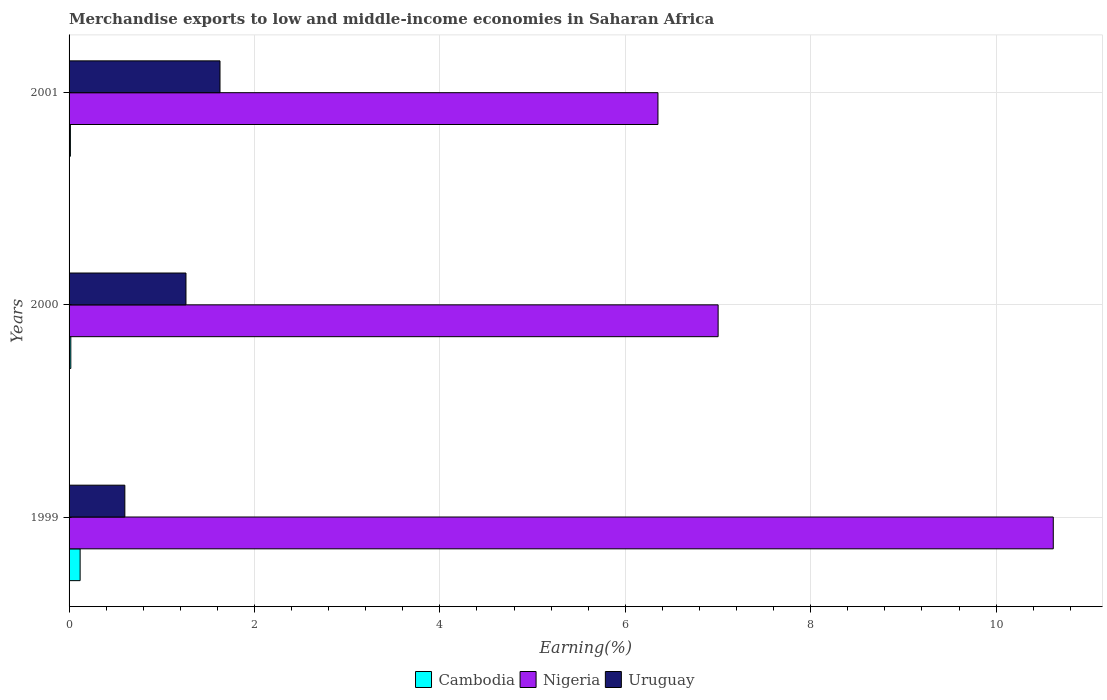Are the number of bars on each tick of the Y-axis equal?
Ensure brevity in your answer.  Yes. How many bars are there on the 2nd tick from the top?
Your response must be concise. 3. How many bars are there on the 3rd tick from the bottom?
Your answer should be compact. 3. What is the label of the 1st group of bars from the top?
Ensure brevity in your answer.  2001. What is the percentage of amount earned from merchandise exports in Nigeria in 2001?
Offer a terse response. 6.35. Across all years, what is the maximum percentage of amount earned from merchandise exports in Uruguay?
Give a very brief answer. 1.63. Across all years, what is the minimum percentage of amount earned from merchandise exports in Nigeria?
Your answer should be very brief. 6.35. What is the total percentage of amount earned from merchandise exports in Cambodia in the graph?
Offer a very short reply. 0.15. What is the difference between the percentage of amount earned from merchandise exports in Nigeria in 1999 and that in 2001?
Your answer should be very brief. 4.26. What is the difference between the percentage of amount earned from merchandise exports in Uruguay in 2000 and the percentage of amount earned from merchandise exports in Nigeria in 2001?
Your answer should be compact. -5.09. What is the average percentage of amount earned from merchandise exports in Uruguay per year?
Offer a terse response. 1.16. In the year 2001, what is the difference between the percentage of amount earned from merchandise exports in Nigeria and percentage of amount earned from merchandise exports in Uruguay?
Your response must be concise. 4.72. What is the ratio of the percentage of amount earned from merchandise exports in Uruguay in 1999 to that in 2001?
Your answer should be very brief. 0.37. Is the difference between the percentage of amount earned from merchandise exports in Nigeria in 1999 and 2001 greater than the difference between the percentage of amount earned from merchandise exports in Uruguay in 1999 and 2001?
Ensure brevity in your answer.  Yes. What is the difference between the highest and the second highest percentage of amount earned from merchandise exports in Nigeria?
Your answer should be very brief. 3.62. What is the difference between the highest and the lowest percentage of amount earned from merchandise exports in Nigeria?
Your answer should be compact. 4.26. In how many years, is the percentage of amount earned from merchandise exports in Uruguay greater than the average percentage of amount earned from merchandise exports in Uruguay taken over all years?
Your answer should be compact. 2. Is the sum of the percentage of amount earned from merchandise exports in Uruguay in 1999 and 2001 greater than the maximum percentage of amount earned from merchandise exports in Nigeria across all years?
Provide a succinct answer. No. What does the 2nd bar from the top in 1999 represents?
Your answer should be compact. Nigeria. What does the 2nd bar from the bottom in 2000 represents?
Keep it short and to the point. Nigeria. How many bars are there?
Give a very brief answer. 9. How many years are there in the graph?
Ensure brevity in your answer.  3. What is the difference between two consecutive major ticks on the X-axis?
Keep it short and to the point. 2. Are the values on the major ticks of X-axis written in scientific E-notation?
Offer a terse response. No. Does the graph contain grids?
Provide a succinct answer. Yes. How many legend labels are there?
Make the answer very short. 3. How are the legend labels stacked?
Make the answer very short. Horizontal. What is the title of the graph?
Your answer should be very brief. Merchandise exports to low and middle-income economies in Saharan Africa. What is the label or title of the X-axis?
Your response must be concise. Earning(%). What is the Earning(%) in Cambodia in 1999?
Offer a terse response. 0.12. What is the Earning(%) in Nigeria in 1999?
Provide a short and direct response. 10.62. What is the Earning(%) in Uruguay in 1999?
Provide a succinct answer. 0.6. What is the Earning(%) of Cambodia in 2000?
Provide a short and direct response. 0.02. What is the Earning(%) in Nigeria in 2000?
Make the answer very short. 7. What is the Earning(%) in Uruguay in 2000?
Ensure brevity in your answer.  1.26. What is the Earning(%) of Cambodia in 2001?
Offer a terse response. 0.01. What is the Earning(%) in Nigeria in 2001?
Give a very brief answer. 6.35. What is the Earning(%) in Uruguay in 2001?
Make the answer very short. 1.63. Across all years, what is the maximum Earning(%) of Cambodia?
Give a very brief answer. 0.12. Across all years, what is the maximum Earning(%) of Nigeria?
Give a very brief answer. 10.62. Across all years, what is the maximum Earning(%) of Uruguay?
Offer a terse response. 1.63. Across all years, what is the minimum Earning(%) of Cambodia?
Give a very brief answer. 0.01. Across all years, what is the minimum Earning(%) of Nigeria?
Provide a short and direct response. 6.35. Across all years, what is the minimum Earning(%) in Uruguay?
Your answer should be compact. 0.6. What is the total Earning(%) of Cambodia in the graph?
Give a very brief answer. 0.15. What is the total Earning(%) in Nigeria in the graph?
Your answer should be very brief. 23.97. What is the total Earning(%) of Uruguay in the graph?
Offer a very short reply. 3.49. What is the difference between the Earning(%) in Cambodia in 1999 and that in 2000?
Your response must be concise. 0.1. What is the difference between the Earning(%) of Nigeria in 1999 and that in 2000?
Ensure brevity in your answer.  3.62. What is the difference between the Earning(%) of Uruguay in 1999 and that in 2000?
Give a very brief answer. -0.66. What is the difference between the Earning(%) in Cambodia in 1999 and that in 2001?
Keep it short and to the point. 0.11. What is the difference between the Earning(%) in Nigeria in 1999 and that in 2001?
Your response must be concise. 4.26. What is the difference between the Earning(%) in Uruguay in 1999 and that in 2001?
Provide a succinct answer. -1.03. What is the difference between the Earning(%) of Cambodia in 2000 and that in 2001?
Give a very brief answer. 0. What is the difference between the Earning(%) in Nigeria in 2000 and that in 2001?
Offer a very short reply. 0.65. What is the difference between the Earning(%) in Uruguay in 2000 and that in 2001?
Provide a short and direct response. -0.37. What is the difference between the Earning(%) of Cambodia in 1999 and the Earning(%) of Nigeria in 2000?
Make the answer very short. -6.88. What is the difference between the Earning(%) of Cambodia in 1999 and the Earning(%) of Uruguay in 2000?
Your answer should be compact. -1.14. What is the difference between the Earning(%) in Nigeria in 1999 and the Earning(%) in Uruguay in 2000?
Keep it short and to the point. 9.36. What is the difference between the Earning(%) in Cambodia in 1999 and the Earning(%) in Nigeria in 2001?
Your response must be concise. -6.23. What is the difference between the Earning(%) in Cambodia in 1999 and the Earning(%) in Uruguay in 2001?
Offer a terse response. -1.51. What is the difference between the Earning(%) of Nigeria in 1999 and the Earning(%) of Uruguay in 2001?
Give a very brief answer. 8.99. What is the difference between the Earning(%) in Cambodia in 2000 and the Earning(%) in Nigeria in 2001?
Provide a short and direct response. -6.33. What is the difference between the Earning(%) of Cambodia in 2000 and the Earning(%) of Uruguay in 2001?
Ensure brevity in your answer.  -1.61. What is the difference between the Earning(%) in Nigeria in 2000 and the Earning(%) in Uruguay in 2001?
Provide a succinct answer. 5.37. What is the average Earning(%) in Cambodia per year?
Provide a short and direct response. 0.05. What is the average Earning(%) in Nigeria per year?
Offer a very short reply. 7.99. What is the average Earning(%) in Uruguay per year?
Provide a short and direct response. 1.16. In the year 1999, what is the difference between the Earning(%) of Cambodia and Earning(%) of Nigeria?
Provide a succinct answer. -10.5. In the year 1999, what is the difference between the Earning(%) in Cambodia and Earning(%) in Uruguay?
Give a very brief answer. -0.48. In the year 1999, what is the difference between the Earning(%) of Nigeria and Earning(%) of Uruguay?
Make the answer very short. 10.02. In the year 2000, what is the difference between the Earning(%) in Cambodia and Earning(%) in Nigeria?
Provide a succinct answer. -6.98. In the year 2000, what is the difference between the Earning(%) in Cambodia and Earning(%) in Uruguay?
Your answer should be very brief. -1.24. In the year 2000, what is the difference between the Earning(%) in Nigeria and Earning(%) in Uruguay?
Make the answer very short. 5.74. In the year 2001, what is the difference between the Earning(%) in Cambodia and Earning(%) in Nigeria?
Offer a very short reply. -6.34. In the year 2001, what is the difference between the Earning(%) of Cambodia and Earning(%) of Uruguay?
Provide a succinct answer. -1.61. In the year 2001, what is the difference between the Earning(%) of Nigeria and Earning(%) of Uruguay?
Your answer should be compact. 4.72. What is the ratio of the Earning(%) in Cambodia in 1999 to that in 2000?
Offer a very short reply. 6.35. What is the ratio of the Earning(%) in Nigeria in 1999 to that in 2000?
Provide a succinct answer. 1.52. What is the ratio of the Earning(%) in Uruguay in 1999 to that in 2000?
Your answer should be very brief. 0.48. What is the ratio of the Earning(%) of Cambodia in 1999 to that in 2001?
Provide a short and direct response. 8.42. What is the ratio of the Earning(%) in Nigeria in 1999 to that in 2001?
Provide a short and direct response. 1.67. What is the ratio of the Earning(%) in Uruguay in 1999 to that in 2001?
Provide a succinct answer. 0.37. What is the ratio of the Earning(%) in Cambodia in 2000 to that in 2001?
Your response must be concise. 1.33. What is the ratio of the Earning(%) of Nigeria in 2000 to that in 2001?
Your response must be concise. 1.1. What is the ratio of the Earning(%) of Uruguay in 2000 to that in 2001?
Ensure brevity in your answer.  0.77. What is the difference between the highest and the second highest Earning(%) in Cambodia?
Offer a terse response. 0.1. What is the difference between the highest and the second highest Earning(%) in Nigeria?
Provide a succinct answer. 3.62. What is the difference between the highest and the second highest Earning(%) in Uruguay?
Your answer should be compact. 0.37. What is the difference between the highest and the lowest Earning(%) in Cambodia?
Provide a succinct answer. 0.11. What is the difference between the highest and the lowest Earning(%) of Nigeria?
Your response must be concise. 4.26. What is the difference between the highest and the lowest Earning(%) in Uruguay?
Offer a terse response. 1.03. 